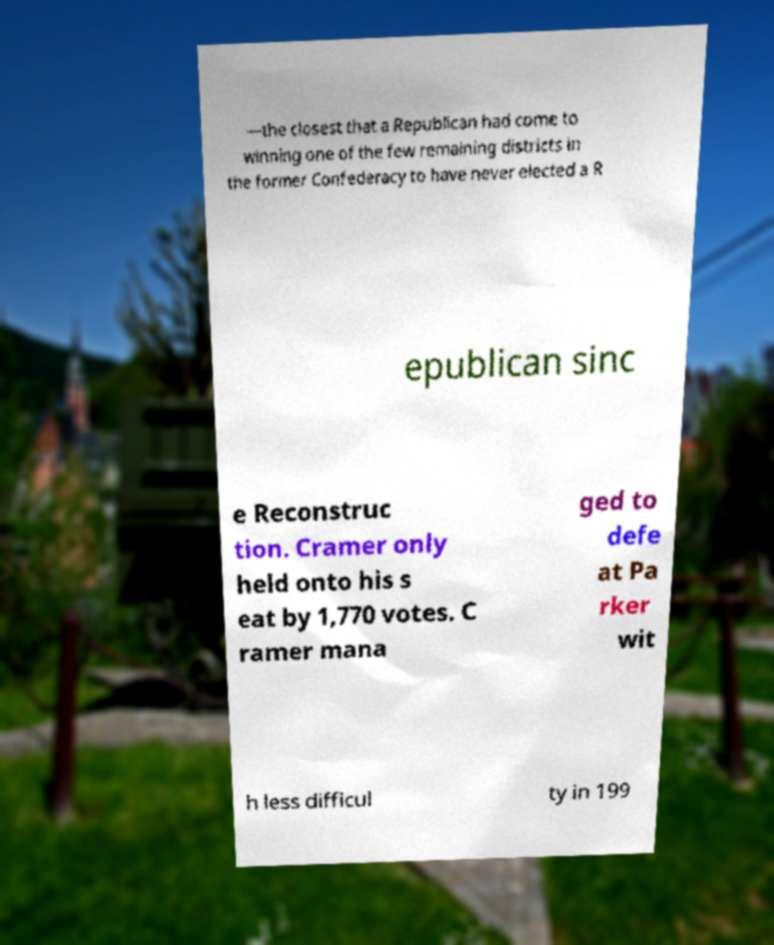Please identify and transcribe the text found in this image. —the closest that a Republican had come to winning one of the few remaining districts in the former Confederacy to have never elected a R epublican sinc e Reconstruc tion. Cramer only held onto his s eat by 1,770 votes. C ramer mana ged to defe at Pa rker wit h less difficul ty in 199 